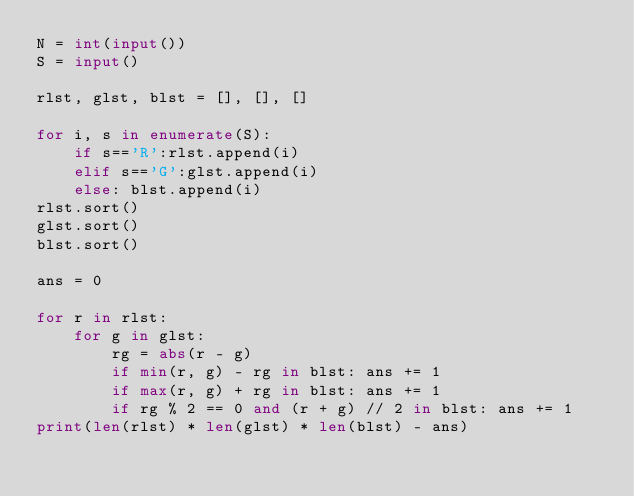Convert code to text. <code><loc_0><loc_0><loc_500><loc_500><_Python_>N = int(input())
S = input()

rlst, glst, blst = [], [], []

for i, s in enumerate(S):
    if s=='R':rlst.append(i)
    elif s=='G':glst.append(i)
    else: blst.append(i)
rlst.sort()
glst.sort()
blst.sort()
      
ans = 0

for r in rlst:
    for g in glst:
        rg = abs(r - g)
        if min(r, g) - rg in blst: ans += 1
        if max(r, g) + rg in blst: ans += 1
        if rg % 2 == 0 and (r + g) // 2 in blst: ans += 1
print(len(rlst) * len(glst) * len(blst) - ans)
        </code> 